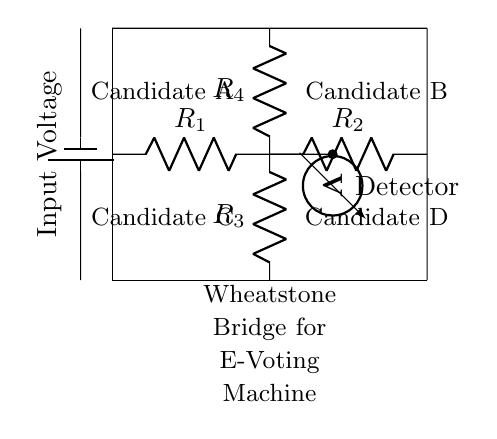What type of circuit is depicted? The circuit is a Wheatstone bridge, which is a specific arrangement of resistors used to measure unknown resistance or detect imbalance. The diagram represents the configuration that is typically used in various applications, including electronic voting machines.
Answer: Wheatstone bridge How many resistors are in the circuit? There are four resistors in this Wheatstone bridge configuration, named R1, R2, R3, and R4 based on their positions in the diagram. Each plays a role in balancing the bridge and determining the voltage across the detector.
Answer: Four What is the role of the voltmeter in the circuit? The voltmeter is used to measure the potential difference between the two branches of the bridge. It indicates whether the bridge is balanced by measuring the voltage at the midpoint. If the voltage is zero, the bridge is balanced, suggesting equal resistance in both branches.
Answer: Measurement What can cause the voltage reading across the voltmeter to change? Changes can occur due to variations in the resistance values of R1, R2, R3, or R4, such as when a candidate's section is selected in the voting machine. Any modification in the resistors will lead to an imbalance, thus changing the voltage reading.
Answer: Resistance changes What does a balanced Wheatstone bridge indicate? A balanced Wheatstone bridge indicates that the ratio of resistances in one branch is equal to the ratio in the other branch, resulting in no voltage difference being detected at the voltmeter. This state confirms that no detection is triggered, which is essential for accurate voting.
Answer: No detection Which candidates are represented in the circuit? The candidates represented in the circuit are A, B, C, and D, indicated by labels on the circuit diagram. The configuration is designed such that each candidate corresponds to a different path through the resistors.
Answer: Candidates A, B, C, D 